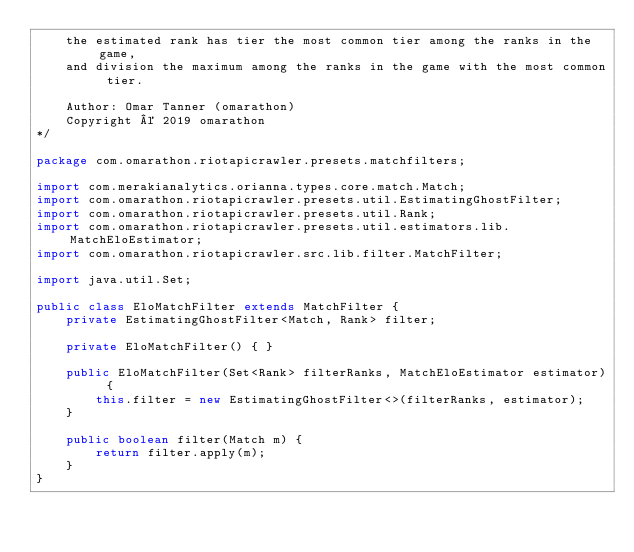<code> <loc_0><loc_0><loc_500><loc_500><_Java_>    the estimated rank has tier the most common tier among the ranks in the game,
    and division the maximum among the ranks in the game with the most common tier.

    Author: Omar Tanner (omarathon)
    Copyright © 2019 omarathon
*/

package com.omarathon.riotapicrawler.presets.matchfilters;

import com.merakianalytics.orianna.types.core.match.Match;
import com.omarathon.riotapicrawler.presets.util.EstimatingGhostFilter;
import com.omarathon.riotapicrawler.presets.util.Rank;
import com.omarathon.riotapicrawler.presets.util.estimators.lib.MatchEloEstimator;
import com.omarathon.riotapicrawler.src.lib.filter.MatchFilter;

import java.util.Set;

public class EloMatchFilter extends MatchFilter {
    private EstimatingGhostFilter<Match, Rank> filter;

    private EloMatchFilter() { }

    public EloMatchFilter(Set<Rank> filterRanks, MatchEloEstimator estimator) {
        this.filter = new EstimatingGhostFilter<>(filterRanks, estimator);
    }

    public boolean filter(Match m) {
        return filter.apply(m);
    }
}
</code> 